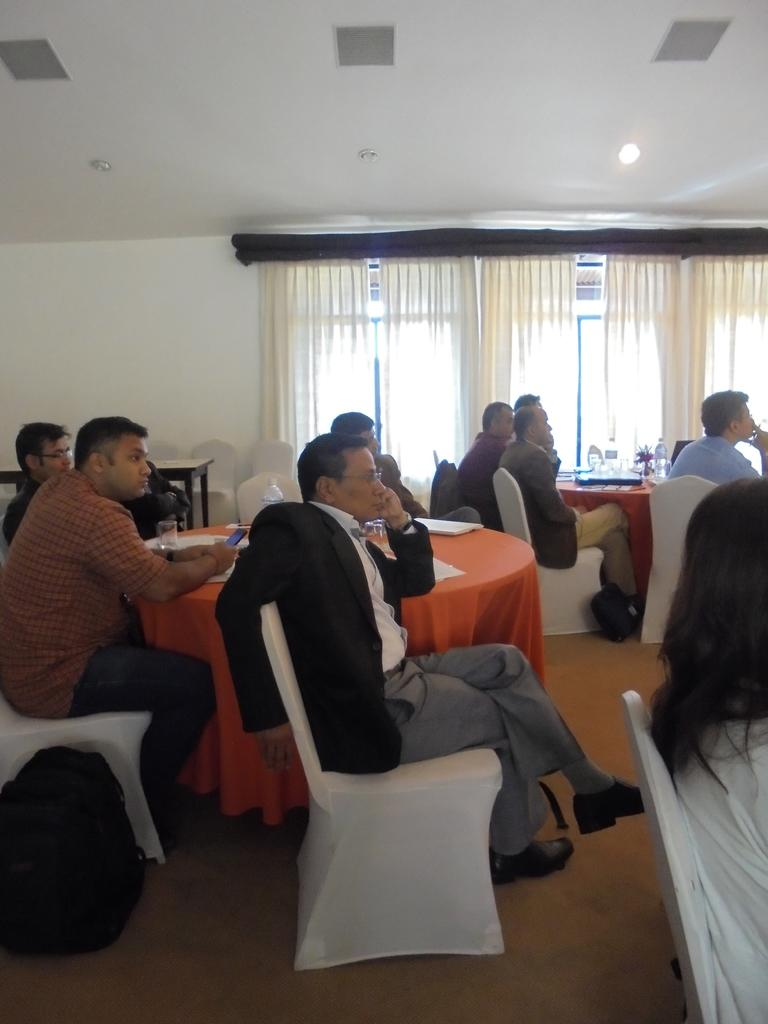How many people are in the image? There is a group of people in the image. What are the people doing in the image? The people are sitting on chairs. What is between the chairs in the image? There is a table between the chairs. What items can be seen on the table? Papers and a glass are present on the table. What can be seen in the background of the image? There are windows in the background of the image. What type of pain is the group of people experiencing in the image? There is no indication of pain in the image; the people are sitting on chairs and there are no visible signs of discomfort. 